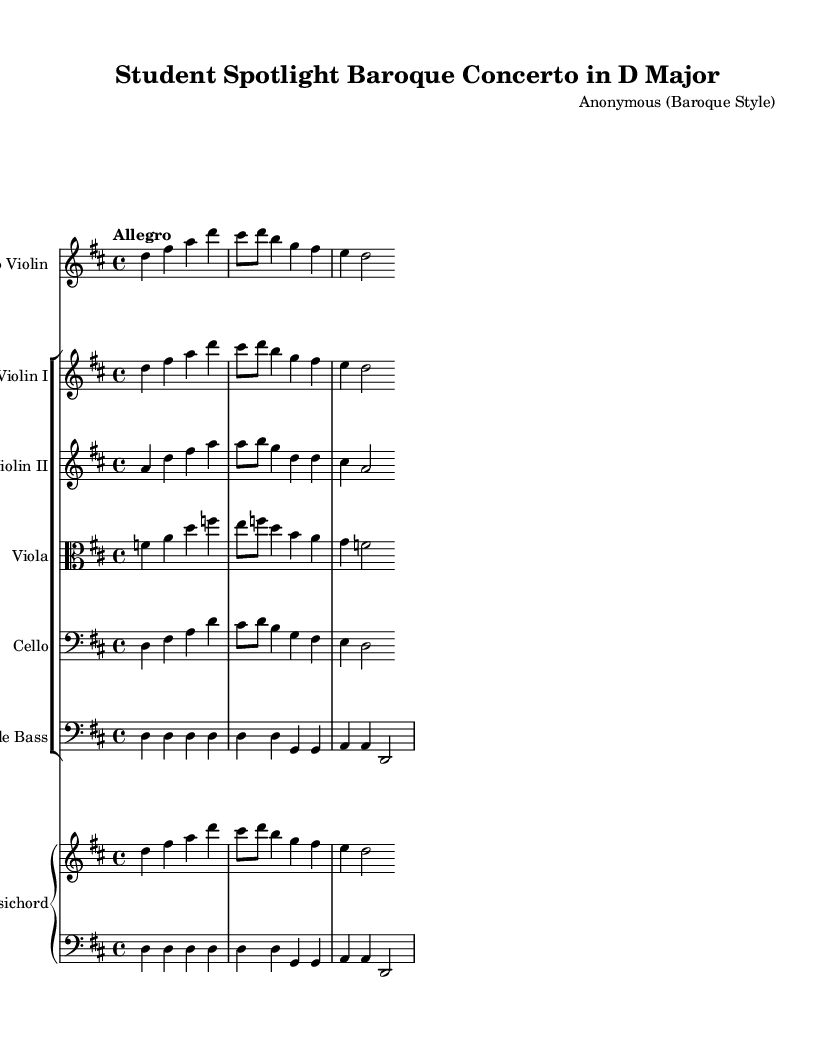What is the key signature of this music? The key signature is indicated by the sharp signs placed at the beginning of the staff. In this case, there is one sharp (F#), which corresponds to the key of D major.
Answer: D major What is the time signature of this music? The time signature is shown at the beginning of the piece in the notation. It is represented as a fraction, with a 4 on the top and a 4 on the bottom, indicating that there are four beats per measure and that the quarter note gets one beat.
Answer: 4/4 What is the tempo marking of this piece? The tempo of the piece is found right at the start, indicated by a word marking. "Allegro" means that the piece should be played at a fast, lively pace.
Answer: Allegro How many instruments are featured in this score? The score shows distinct staves for different instruments. Counting them, there are six different staves—one for solo violin, one for violin I, one for violin II, one for viola, one for cello, and a piano staff for the harpsichord (which has two staves for left and right).
Answer: Six What is the role of the harpsichord in this concerto? The harpsichord has two staves, indicating it plays both the right hand (melody/harmony) and left hand (bass line). This supports the full orchestra accompaniment and often realizes the continuo part typical of Baroque concertos.
Answer: Continuo Which instrument has the solo part? The solo part is denoted at the very beginning of the score, where "Solo Violin" is indicated. This means that the violin plays a prominent role above the orchestral accompaniment.
Answer: Solo Violin 